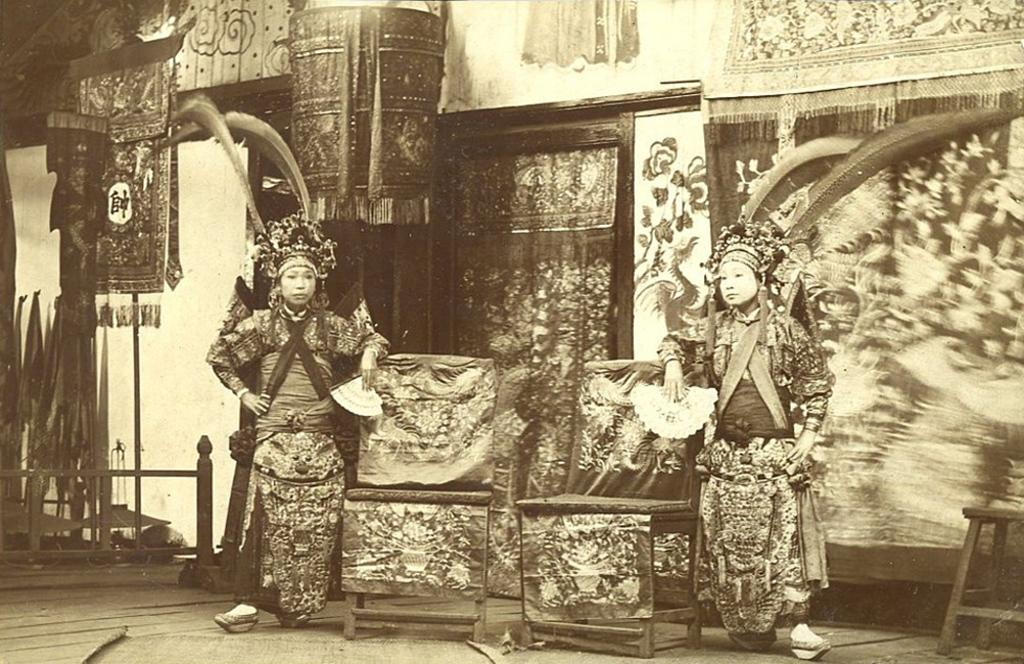How many people are in the image? There are two persons in the image. What are the two persons doing in the image? The two persons are standing beside two chairs. What can be seen in the background of the image? There is a door, curtains, a fence, and a tool in the background of the image. What type of word is being used by the farmer in the image? There is no farmer present in the image, and therefore no one is using any words. How many pizzas are being prepared by the persons in the image? There are no pizzas present in the image; the two persons are standing beside two chairs. 